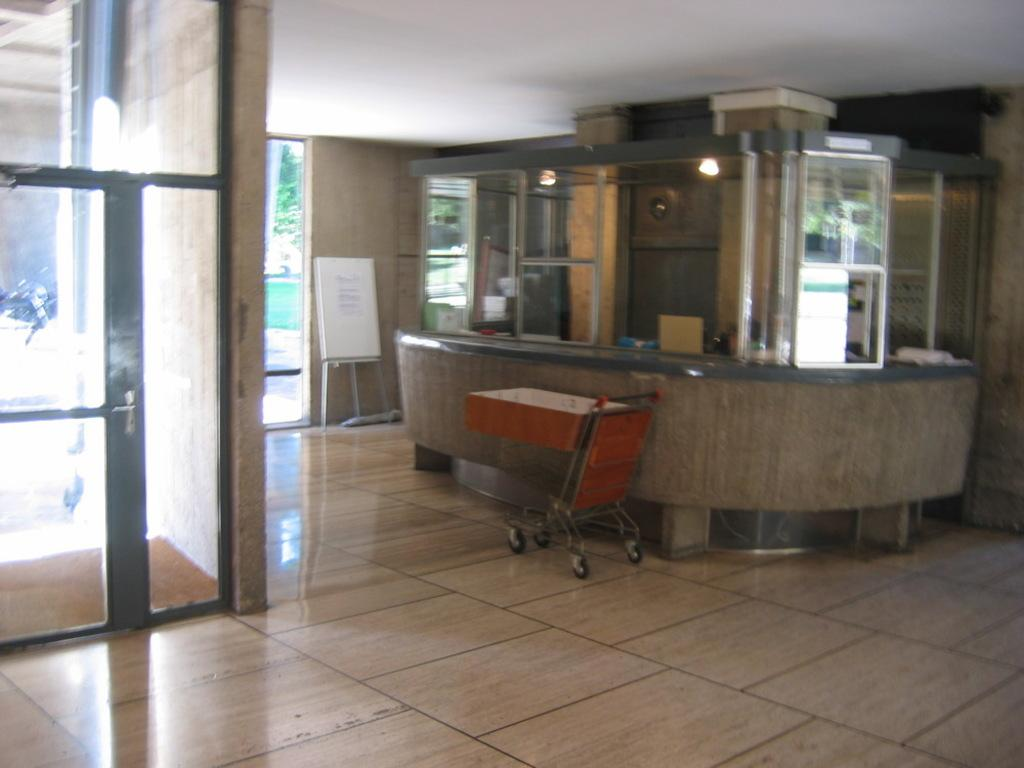What type of furniture or equipment is present in the room? There is a trolley in the room. What is the primary purpose of the room? The presence of a reception desk suggests that the room is likely a reception area or lobby. How can people enter or exit the room? There are doors in the room for entering and exiting. What can be used for displaying information or announcements? There is a board in the room for displaying information or announcements. How many cows are grazing in the room? There are no cows present in the room; the image does not depict any animals. Is there a cactus growing on the board in the room? There is no cactus present in the room; the image only shows a board for displaying information or announcements. 